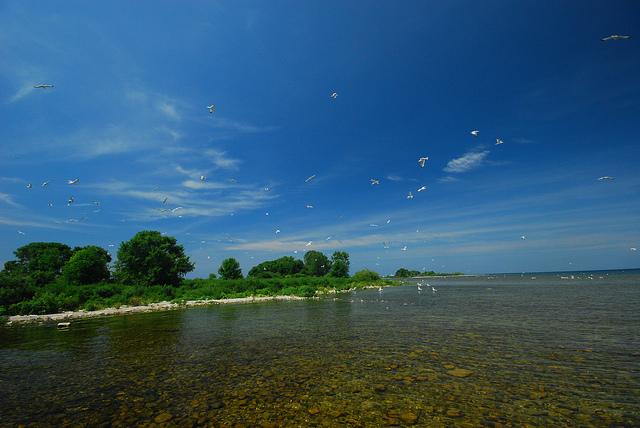What season does it appear to be?
Write a very short answer. Summer. Why isn't the water in the foreground reflecting light very well?
Keep it brief. Clear. Is the water deep?
Be succinct. No. Is it morning?
Quick response, please. Yes. What animals are drinking?
Write a very short answer. Birds. Is it a clear sunny day?
Write a very short answer. Yes. Does the water look clean?
Be succinct. Yes. Is it about to rain?
Quick response, please. No. Is this a sunny day?
Answer briefly. Yes. What color is the water?
Keep it brief. Brown. Is this the middle of the day?
Concise answer only. Yes. Is it autumn?
Be succinct. No. Is the water moving?
Keep it brief. Yes. What type of birds are flying over the water?
Short answer required. Seagulls. Can you see any cars?
Answer briefly. No. What percentage of the picture is water?
Answer briefly. 45. Is sunset?
Give a very brief answer. No. 